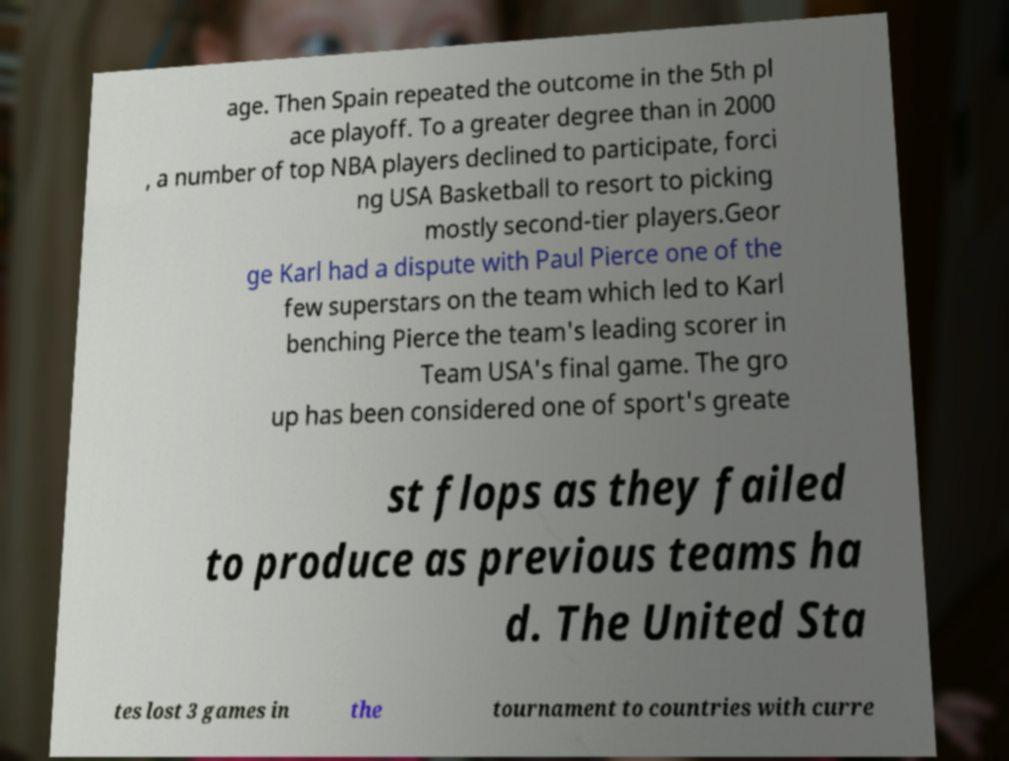Can you read and provide the text displayed in the image?This photo seems to have some interesting text. Can you extract and type it out for me? age. Then Spain repeated the outcome in the 5th pl ace playoff. To a greater degree than in 2000 , a number of top NBA players declined to participate, forci ng USA Basketball to resort to picking mostly second-tier players.Geor ge Karl had a dispute with Paul Pierce one of the few superstars on the team which led to Karl benching Pierce the team's leading scorer in Team USA's final game. The gro up has been considered one of sport's greate st flops as they failed to produce as previous teams ha d. The United Sta tes lost 3 games in the tournament to countries with curre 